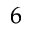<formula> <loc_0><loc_0><loc_500><loc_500>_ { 6 }</formula> 